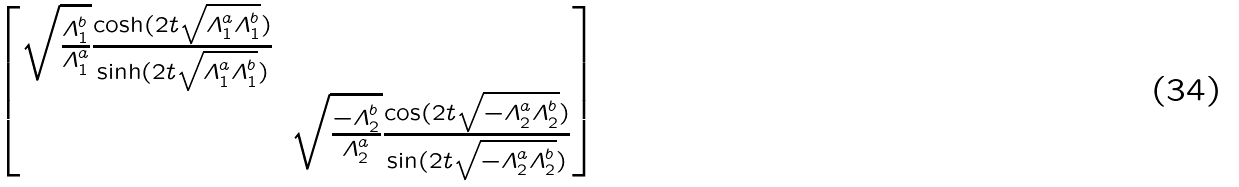<formula> <loc_0><loc_0><loc_500><loc_500>\begin{bmatrix} \sqrt { \frac { \varLambda _ { 1 } ^ { b } } { \varLambda _ { 1 } ^ { a } } } \frac { \cosh ( 2 t \sqrt { \varLambda _ { 1 } ^ { a } \varLambda _ { 1 } ^ { b } } ) } { \sinh ( 2 t \sqrt { \varLambda _ { 1 } ^ { a } \varLambda _ { 1 } ^ { b } } ) } & \\ & \sqrt { \frac { - \varLambda _ { 2 } ^ { b } } { \varLambda _ { 2 } ^ { a } } } \frac { \cos ( 2 t \sqrt { - \varLambda _ { 2 } ^ { a } \varLambda _ { 2 } ^ { b } } ) } { \sin ( 2 t \sqrt { - \varLambda _ { 2 } ^ { a } \varLambda _ { 2 } ^ { b } } ) } \end{bmatrix}</formula> 